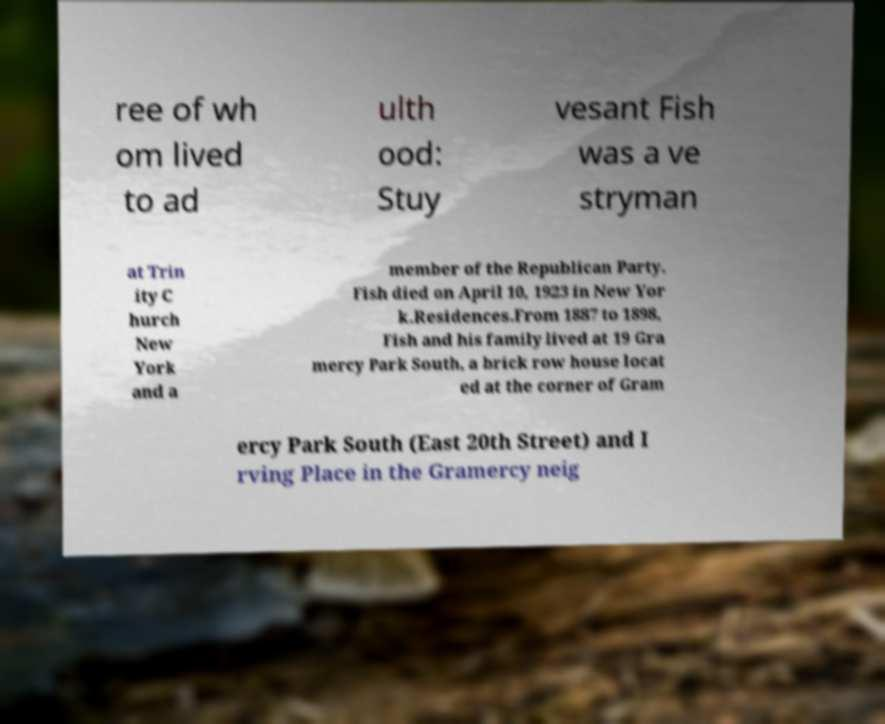What messages or text are displayed in this image? I need them in a readable, typed format. ree of wh om lived to ad ulth ood: Stuy vesant Fish was a ve stryman at Trin ity C hurch New York and a member of the Republican Party. Fish died on April 10, 1923 in New Yor k.Residences.From 1887 to 1898, Fish and his family lived at 19 Gra mercy Park South, a brick row house locat ed at the corner of Gram ercy Park South (East 20th Street) and I rving Place in the Gramercy neig 